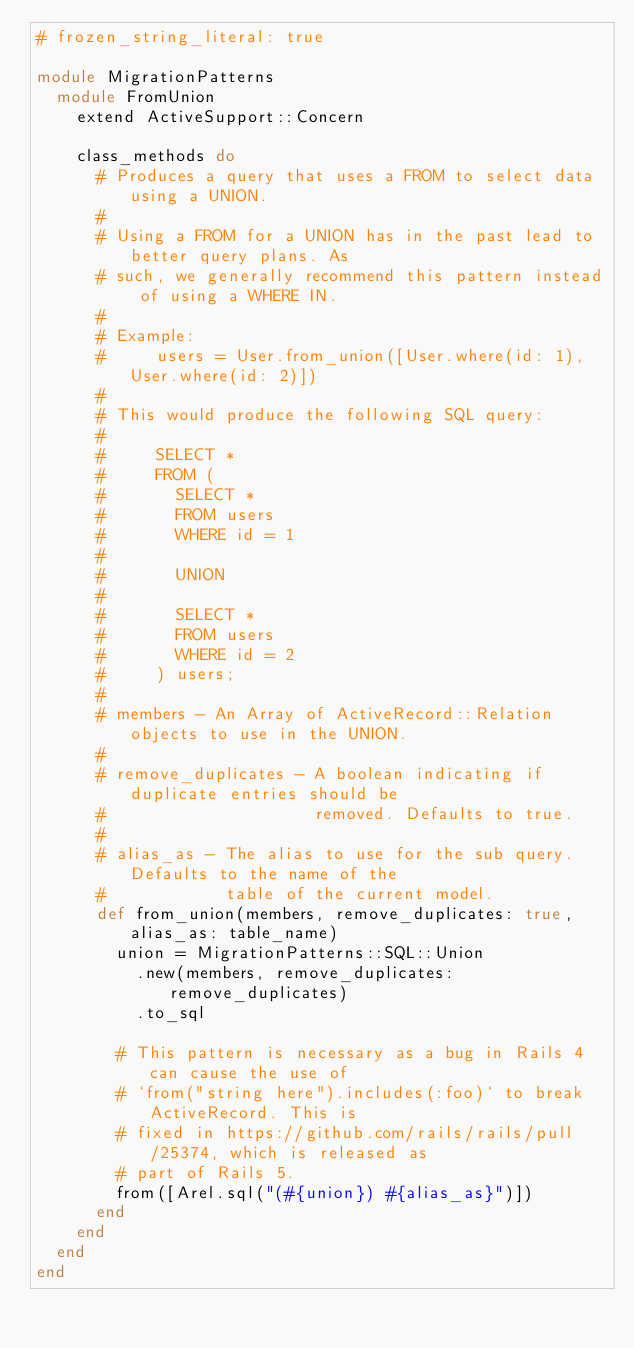<code> <loc_0><loc_0><loc_500><loc_500><_Ruby_># frozen_string_literal: true

module MigrationPatterns
  module FromUnion
    extend ActiveSupport::Concern

    class_methods do
      # Produces a query that uses a FROM to select data using a UNION.
      #
      # Using a FROM for a UNION has in the past lead to better query plans. As
      # such, we generally recommend this pattern instead of using a WHERE IN.
      #
      # Example:
      #     users = User.from_union([User.where(id: 1), User.where(id: 2)])
      #
      # This would produce the following SQL query:
      #
      #     SELECT *
      #     FROM (
      #       SELECT *
      #       FROM users
      #       WHERE id = 1
      #
      #       UNION
      #
      #       SELECT *
      #       FROM users
      #       WHERE id = 2
      #     ) users;
      #
      # members - An Array of ActiveRecord::Relation objects to use in the UNION.
      #
      # remove_duplicates - A boolean indicating if duplicate entries should be
      #                     removed. Defaults to true.
      #
      # alias_as - The alias to use for the sub query. Defaults to the name of the
      #            table of the current model.
      def from_union(members, remove_duplicates: true, alias_as: table_name)
        union = MigrationPatterns::SQL::Union
          .new(members, remove_duplicates: remove_duplicates)
          .to_sql

        # This pattern is necessary as a bug in Rails 4 can cause the use of
        # `from("string here").includes(:foo)` to break ActiveRecord. This is
        # fixed in https://github.com/rails/rails/pull/25374, which is released as
        # part of Rails 5.
        from([Arel.sql("(#{union}) #{alias_as}")])
      end
    end
  end
end
</code> 